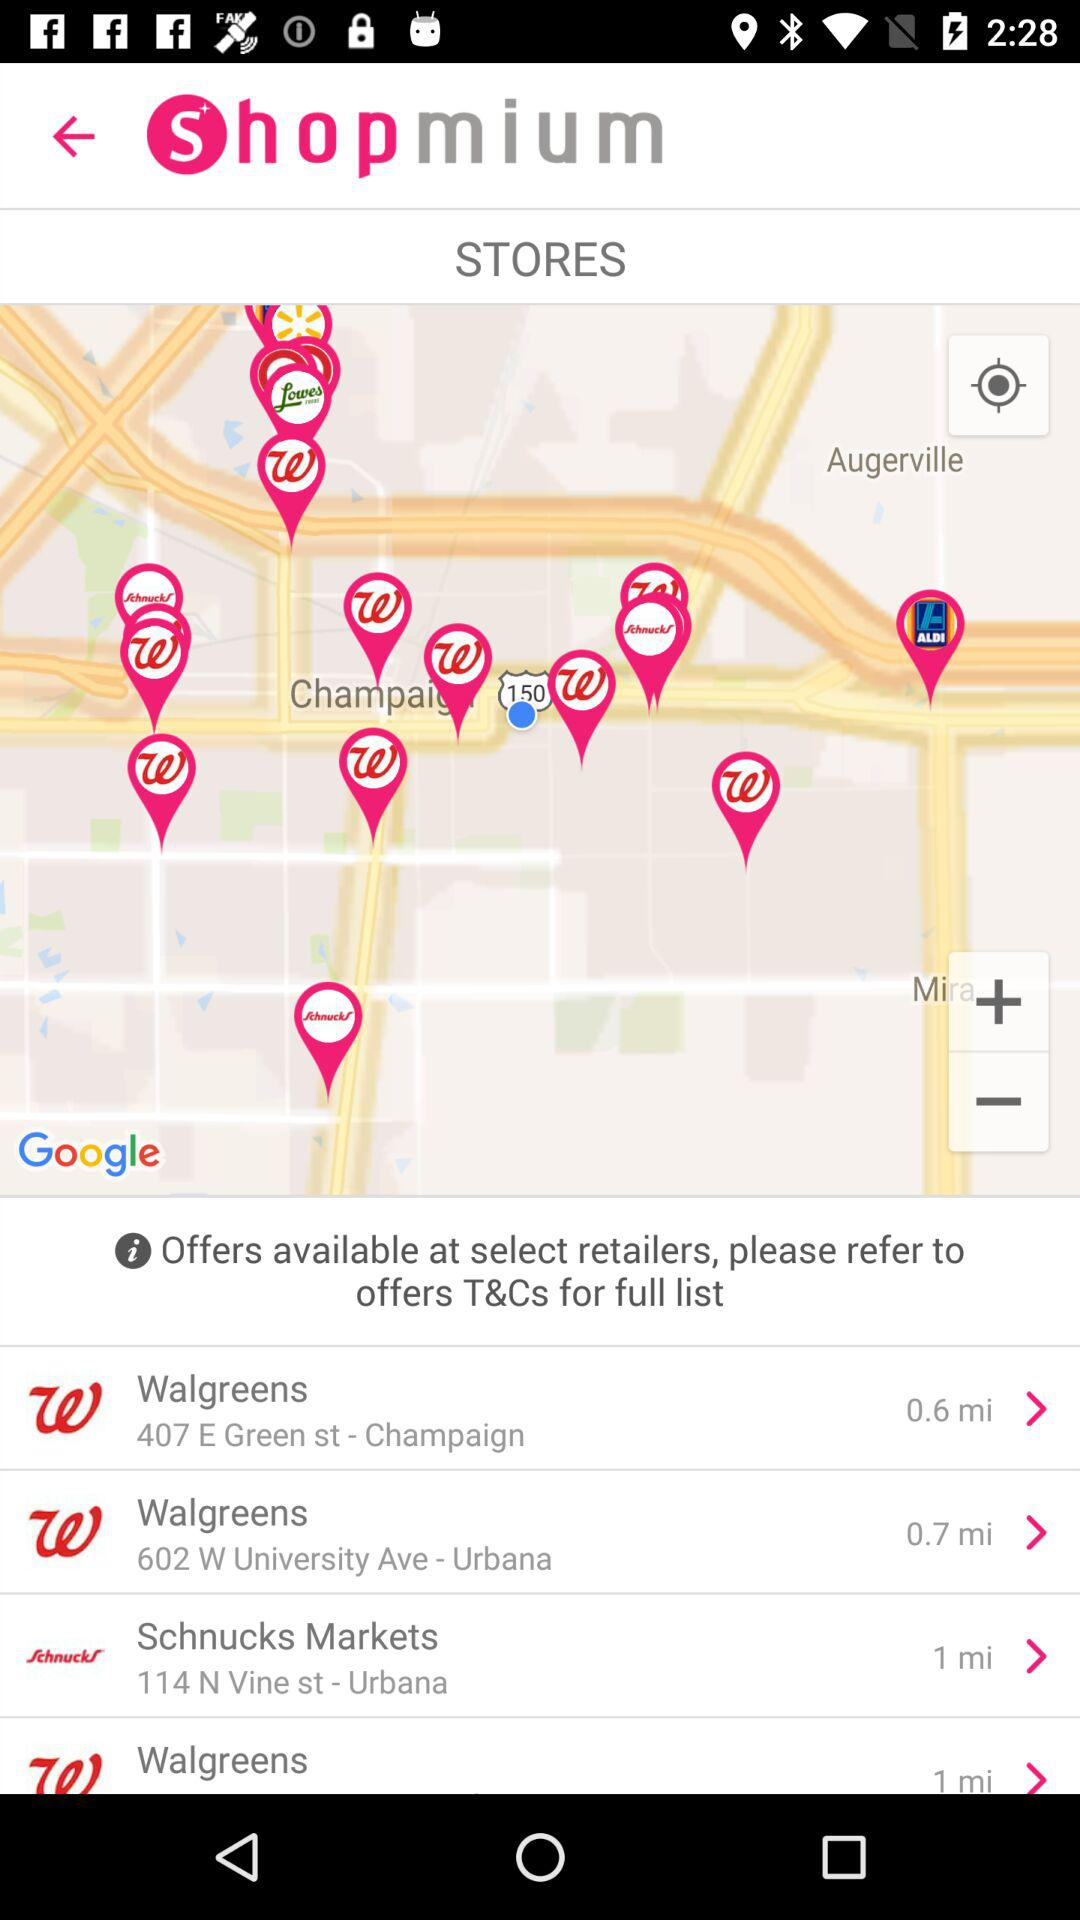What is the distance of "Walgreens" located in Champaign, from my location? The distance is 0.6 miles. 